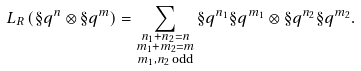<formula> <loc_0><loc_0><loc_500><loc_500>L _ { R } \left ( \S q ^ { n } \otimes \S q ^ { m } \right ) & = \sum _ { \substack { n _ { 1 } + n _ { 2 } = n \\ m _ { 1 } + m _ { 2 } = m \\ m _ { 1 } , n _ { 2 } \, \text {odd} } } \S q ^ { n _ { 1 } } \S q ^ { m _ { 1 } } \otimes \S q ^ { n _ { 2 } } \S q ^ { m _ { 2 } } .</formula> 